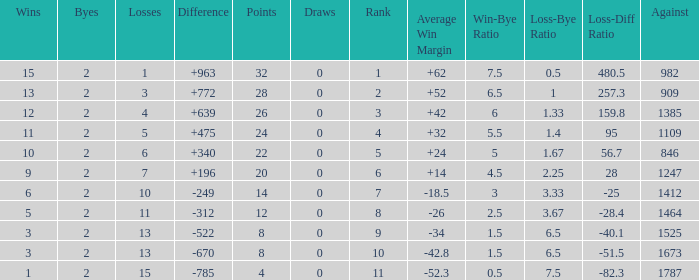What is the average number of Byes when there were less than 0 losses and were against 1247? None. 